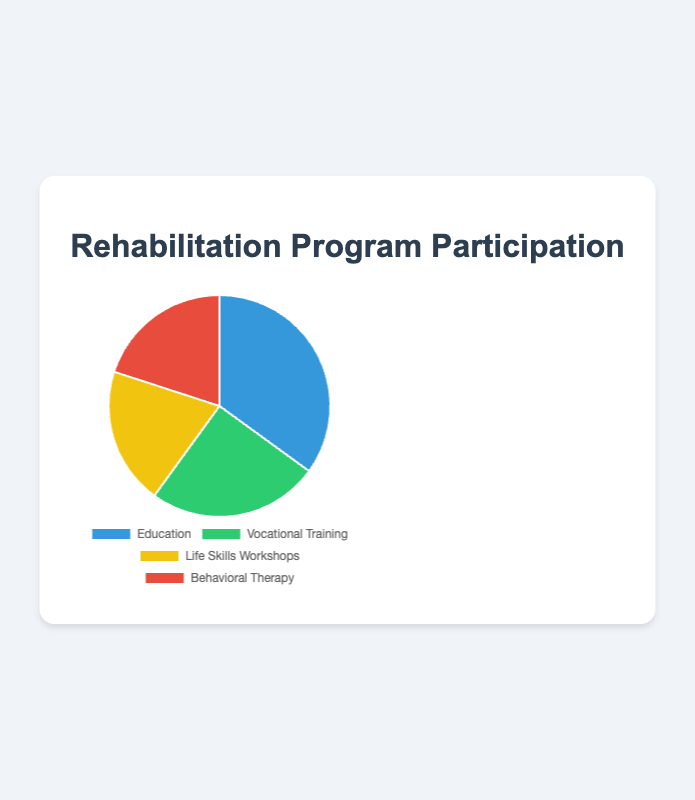What percentage of participation does the Education program have? The Education slice corresponds to 35%, as provided in the dataset.
Answer: 35% Which program has the least participation? The Life Skills Workshops and Behavioral Therapy both have the smallest slices, corresponding to 20% each.
Answer: Life Skills Workshops and Behavioral Therapy Sum the participation percentages of Vocational Training and Life Skills Workshops. Vocational Training has 25% and Life Skills Workshops have 20%. Summing these gives 25% + 20% = 45%.
Answer: 45% Is the participation in the Education program greater than the combined participation in both Life Skills Workshops and Behavioral Therapy? Participation in Education is 35%. Combined participation in Life Skills Workshops and Behavioral Therapy is 20% + 20% = 40%. (35% < 40%)
Answer: No Which program has the second highest participation? After Education, which has 35%, the next highest participation is Vocational Training with 25%.
Answer: Vocational Training If another program category with 10% participation were added, what would the new total percentage participation be across all programs? Current total is 35% + 25% + 20% + 20% = 100%. Adding 10% gives 100% + 10% = 110%.
Answer: 110% What is the average participation percentage of all programs? The total percentage is 35% + 25% + 20% + 20% = 100%. There are 4 programs, so the average is 100% / 4 = 25%.
Answer: 25% Which color represents the Behavioral Therapy slice in the pie chart? The Behavioral Therapy slice is represented by the red color (last color listed).
Answer: Red 